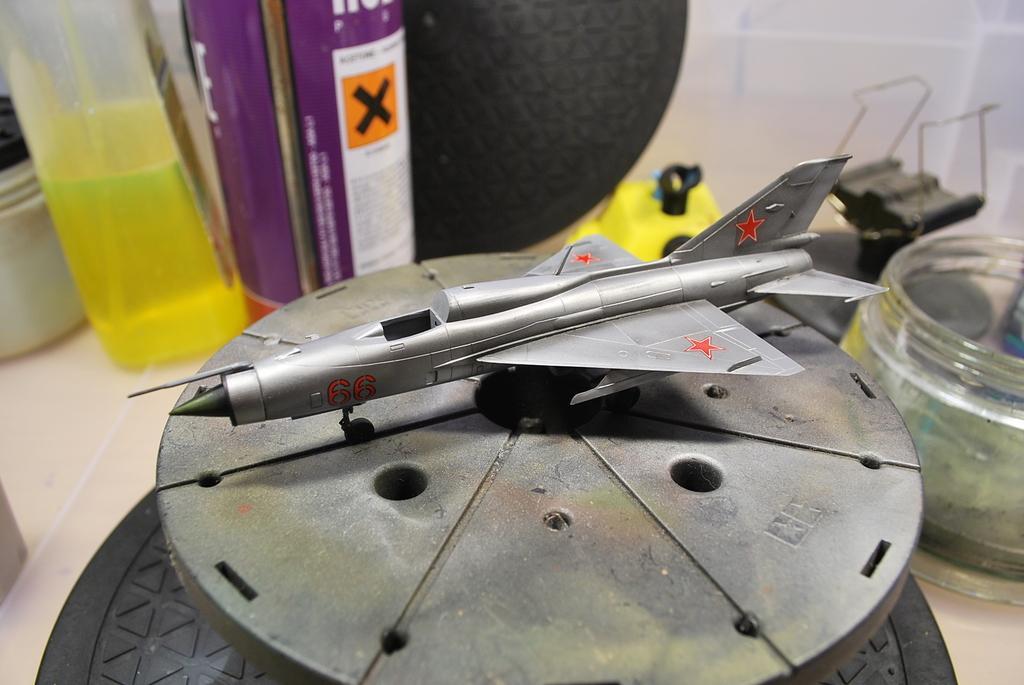Please provide a concise description of this image. In the middle of the image we can see miniature of a plane, in the background we can see few bottles and other things, also we can see liquid in the bottle. 